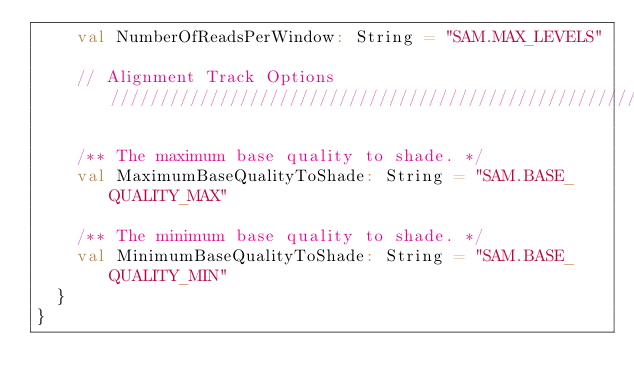Convert code to text. <code><loc_0><loc_0><loc_500><loc_500><_Scala_>    val NumberOfReadsPerWindow: String = "SAM.MAX_LEVELS"

    // Alignment Track Options /////////////////////////////////////////////////////////////////////////////////////////

    /** The maximum base quality to shade. */
    val MaximumBaseQualityToShade: String = "SAM.BASE_QUALITY_MAX"

    /** The minimum base quality to shade. */
    val MinimumBaseQualityToShade: String = "SAM.BASE_QUALITY_MIN"
  }
}
</code> 